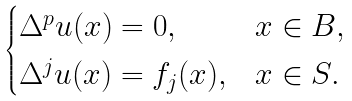<formula> <loc_0><loc_0><loc_500><loc_500>\begin{cases} \Delta ^ { p } u ( x ) = 0 , & x \in B , \\ \Delta ^ { j } u ( x ) = f _ { j } ( x ) , & x \in S . \end{cases}</formula> 